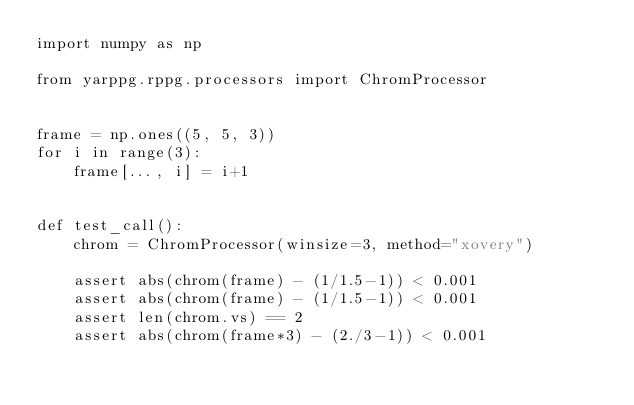<code> <loc_0><loc_0><loc_500><loc_500><_Python_>import numpy as np

from yarppg.rppg.processors import ChromProcessor


frame = np.ones((5, 5, 3))
for i in range(3):
    frame[..., i] = i+1


def test_call():
    chrom = ChromProcessor(winsize=3, method="xovery")

    assert abs(chrom(frame) - (1/1.5-1)) < 0.001
    assert abs(chrom(frame) - (1/1.5-1)) < 0.001
    assert len(chrom.vs) == 2
    assert abs(chrom(frame*3) - (2./3-1)) < 0.001
</code> 